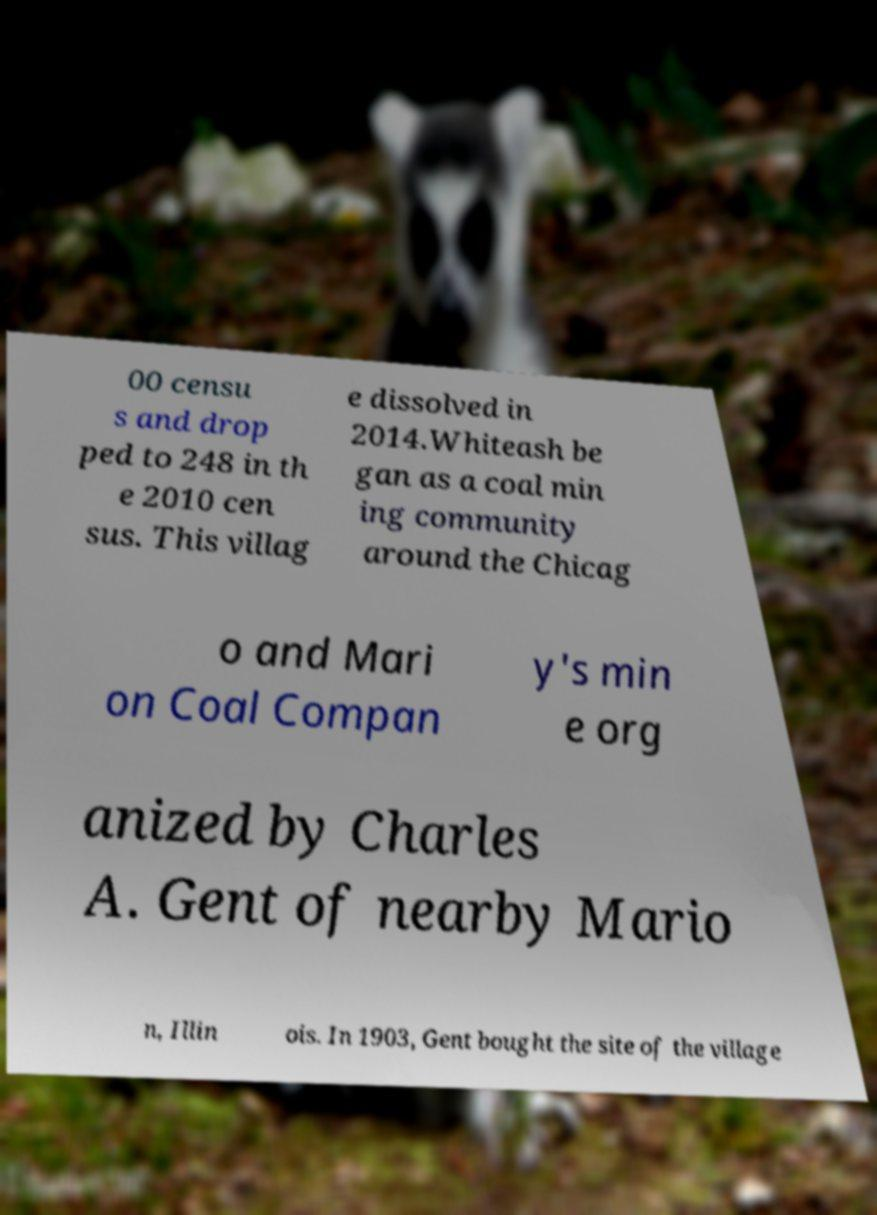Could you assist in decoding the text presented in this image and type it out clearly? 00 censu s and drop ped to 248 in th e 2010 cen sus. This villag e dissolved in 2014.Whiteash be gan as a coal min ing community around the Chicag o and Mari on Coal Compan y's min e org anized by Charles A. Gent of nearby Mario n, Illin ois. In 1903, Gent bought the site of the village 